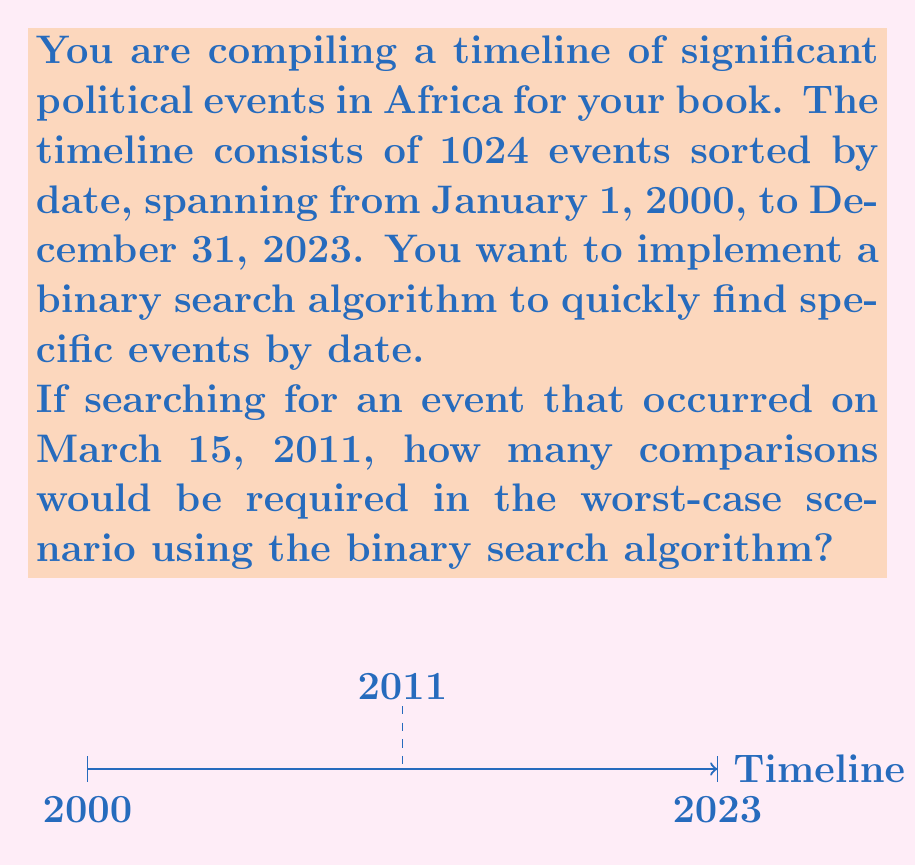Show me your answer to this math problem. Let's approach this step-by-step:

1) The binary search algorithm works by repeatedly dividing the search interval in half. The worst-case scenario occurs when the target element is at one of the ends of the array or not present in the array.

2) The number of comparisons in the worst case is given by $\lceil \log_2 n \rceil$, where $n$ is the number of elements in the sorted array.

3) In this case, $n = 1024$ events.

4) Let's calculate:

   $$\lceil \log_2 1024 \rceil = \lceil 10 \rceil = 10$$

5) To verify:
   - 1st comparison: 512 elements left
   - 2nd comparison: 256 elements left
   - 3rd comparison: 128 elements left
   - 4th comparison: 64 elements left
   - 5th comparison: 32 elements left
   - 6th comparison: 16 elements left
   - 7th comparison: 8 elements left
   - 8th comparison: 4 elements left
   - 9th comparison: 2 elements left
   - 10th comparison: 1 element left (found or not found)

Therefore, in the worst-case scenario, 10 comparisons would be required to find the event on March 15, 2011, or to determine that it's not in the timeline.
Answer: 10 comparisons 